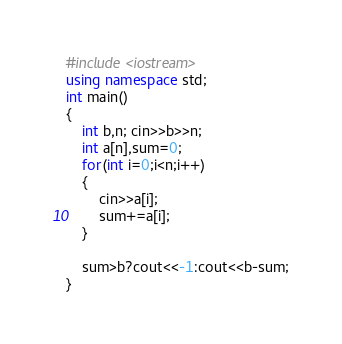<code> <loc_0><loc_0><loc_500><loc_500><_C++_>#include <iostream> 
using namespace std;
int main()
{
	int b,n; cin>>b>>n;
	int a[n],sum=0;
	for(int i=0;i<n;i++) 
	{
		cin>>a[i];
		sum+=a[i];
	}
	
	sum>b?cout<<-1:cout<<b-sum;
}
</code> 